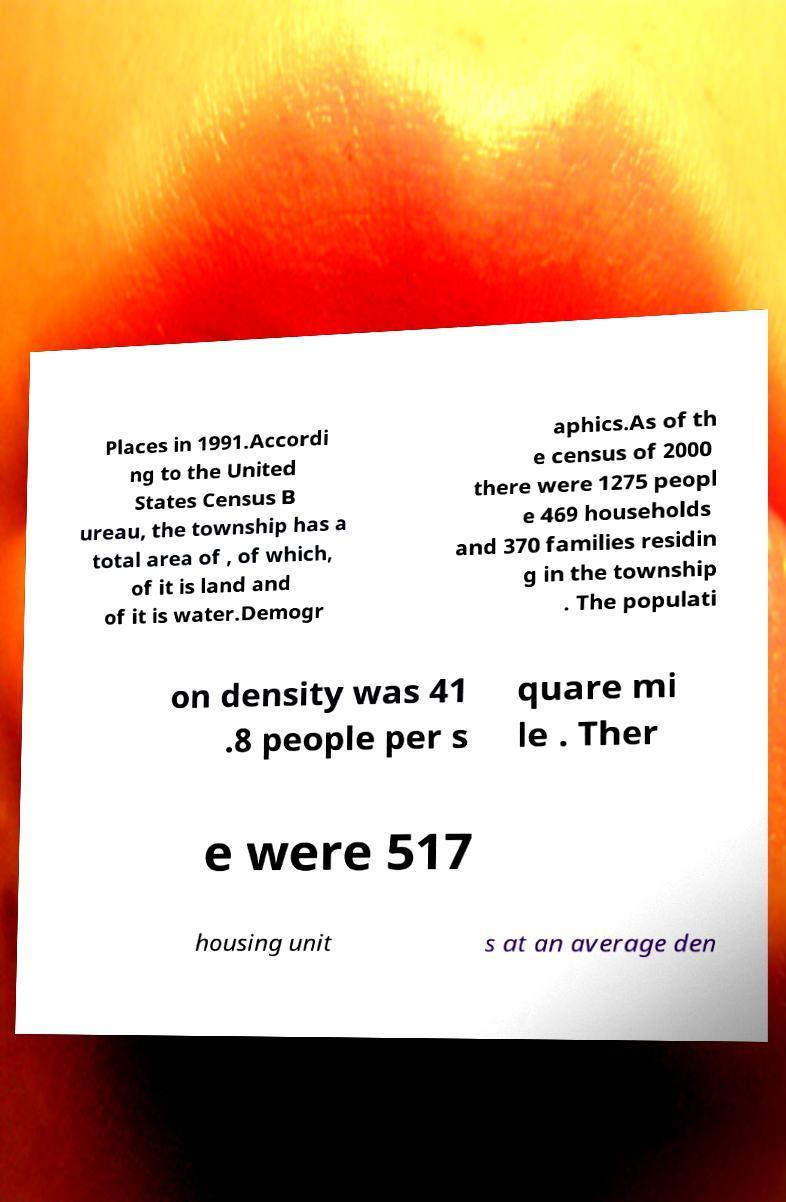Can you accurately transcribe the text from the provided image for me? Places in 1991.Accordi ng to the United States Census B ureau, the township has a total area of , of which, of it is land and of it is water.Demogr aphics.As of th e census of 2000 there were 1275 peopl e 469 households and 370 families residin g in the township . The populati on density was 41 .8 people per s quare mi le . Ther e were 517 housing unit s at an average den 